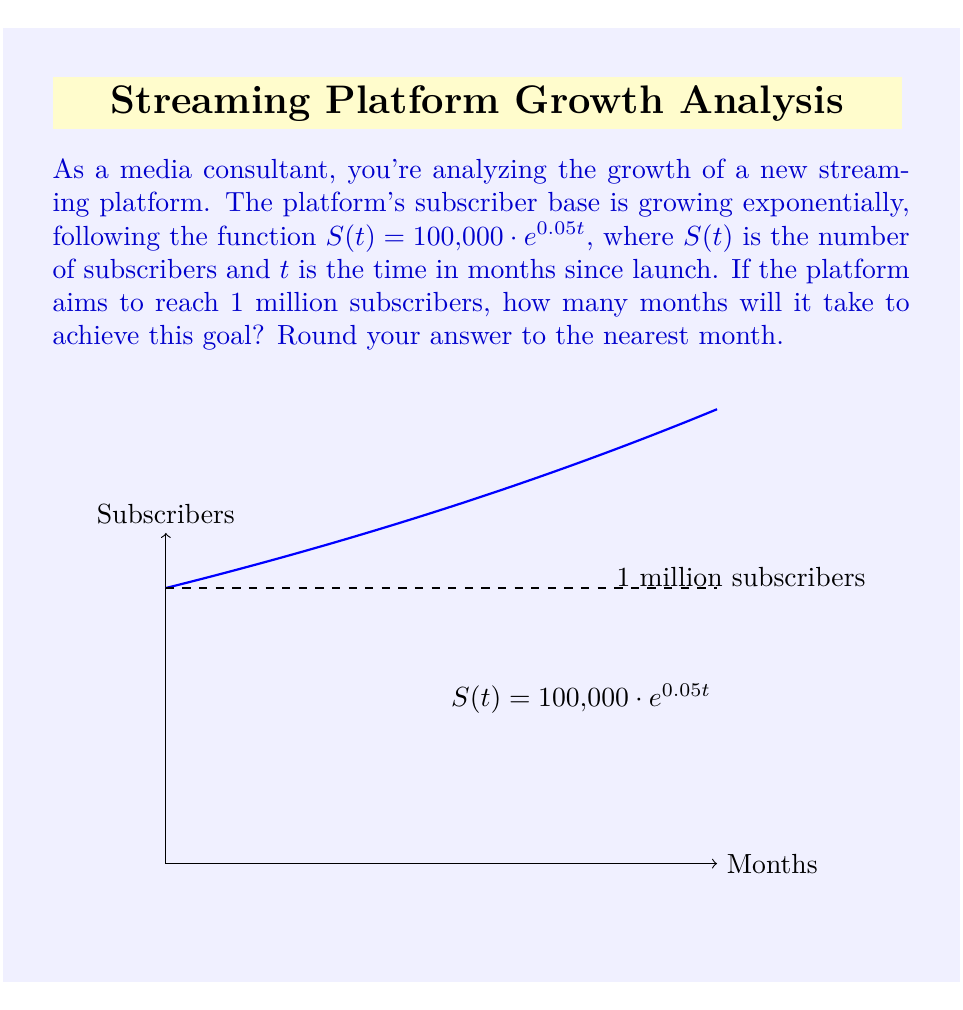Could you help me with this problem? Let's approach this step-by-step:

1) We need to find $t$ when $S(t) = 1,000,000$. So, we set up the equation:

   $1,000,000 = 100,000 \cdot e^{0.05t}$

2) Divide both sides by 100,000:

   $10 = e^{0.05t}$

3) Take the natural logarithm of both sides:

   $\ln(10) = \ln(e^{0.05t})$

4) Simplify the right side using the properties of logarithms:

   $\ln(10) = 0.05t$

5) Solve for $t$:

   $t = \frac{\ln(10)}{0.05}$

6) Calculate the result:

   $t = \frac{2.30258509...}{0.05} = 46.05170185...$

7) Round to the nearest month:

   $t \approx 46$ months
Answer: 46 months 